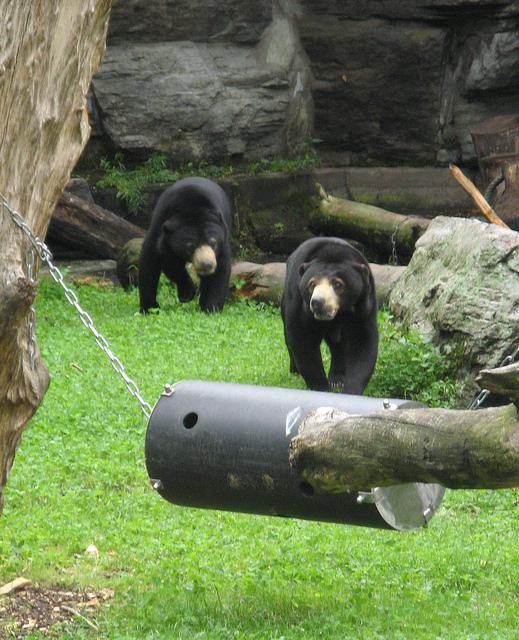How many animals are in this picture?
Answer briefly. 2. What type of animal is in this picture?
Concise answer only. Bear. What color are the bears?
Write a very short answer. Black. 